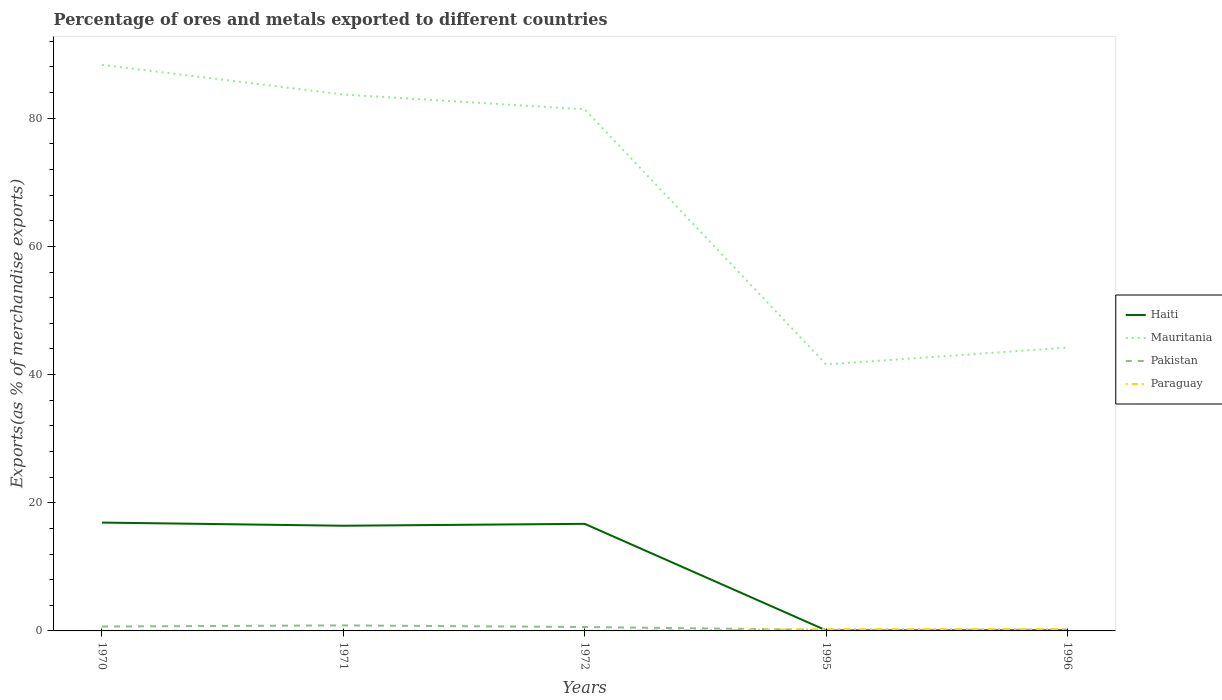Across all years, what is the maximum percentage of exports to different countries in Pakistan?
Offer a very short reply. 0.16. What is the total percentage of exports to different countries in Pakistan in the graph?
Give a very brief answer. -0.06. What is the difference between the highest and the second highest percentage of exports to different countries in Haiti?
Your answer should be compact. 16.82. What is the difference between the highest and the lowest percentage of exports to different countries in Mauritania?
Your answer should be very brief. 3. Where does the legend appear in the graph?
Offer a very short reply. Center right. How are the legend labels stacked?
Keep it short and to the point. Vertical. What is the title of the graph?
Ensure brevity in your answer.  Percentage of ores and metals exported to different countries. Does "Cameroon" appear as one of the legend labels in the graph?
Your answer should be compact. No. What is the label or title of the Y-axis?
Your answer should be very brief. Exports(as % of merchandise exports). What is the Exports(as % of merchandise exports) in Haiti in 1970?
Your answer should be compact. 16.91. What is the Exports(as % of merchandise exports) of Mauritania in 1970?
Your answer should be compact. 88.32. What is the Exports(as % of merchandise exports) in Pakistan in 1970?
Your response must be concise. 0.69. What is the Exports(as % of merchandise exports) in Paraguay in 1970?
Give a very brief answer. 0.03. What is the Exports(as % of merchandise exports) of Haiti in 1971?
Your answer should be compact. 16.41. What is the Exports(as % of merchandise exports) of Mauritania in 1971?
Make the answer very short. 83.7. What is the Exports(as % of merchandise exports) of Pakistan in 1971?
Offer a very short reply. 0.86. What is the Exports(as % of merchandise exports) of Paraguay in 1971?
Provide a short and direct response. 0.02. What is the Exports(as % of merchandise exports) in Haiti in 1972?
Make the answer very short. 16.71. What is the Exports(as % of merchandise exports) in Mauritania in 1972?
Ensure brevity in your answer.  81.38. What is the Exports(as % of merchandise exports) of Pakistan in 1972?
Provide a succinct answer. 0.61. What is the Exports(as % of merchandise exports) in Paraguay in 1972?
Make the answer very short. 0. What is the Exports(as % of merchandise exports) in Haiti in 1995?
Your answer should be compact. 0.09. What is the Exports(as % of merchandise exports) in Mauritania in 1995?
Your answer should be compact. 41.58. What is the Exports(as % of merchandise exports) in Pakistan in 1995?
Your answer should be very brief. 0.16. What is the Exports(as % of merchandise exports) of Paraguay in 1995?
Your response must be concise. 0.27. What is the Exports(as % of merchandise exports) of Haiti in 1996?
Make the answer very short. 0.1. What is the Exports(as % of merchandise exports) of Mauritania in 1996?
Offer a terse response. 44.21. What is the Exports(as % of merchandise exports) of Pakistan in 1996?
Offer a very short reply. 0.22. What is the Exports(as % of merchandise exports) of Paraguay in 1996?
Offer a terse response. 0.28. Across all years, what is the maximum Exports(as % of merchandise exports) in Haiti?
Offer a terse response. 16.91. Across all years, what is the maximum Exports(as % of merchandise exports) of Mauritania?
Your answer should be very brief. 88.32. Across all years, what is the maximum Exports(as % of merchandise exports) of Pakistan?
Make the answer very short. 0.86. Across all years, what is the maximum Exports(as % of merchandise exports) in Paraguay?
Make the answer very short. 0.28. Across all years, what is the minimum Exports(as % of merchandise exports) of Haiti?
Your response must be concise. 0.09. Across all years, what is the minimum Exports(as % of merchandise exports) in Mauritania?
Ensure brevity in your answer.  41.58. Across all years, what is the minimum Exports(as % of merchandise exports) of Pakistan?
Make the answer very short. 0.16. Across all years, what is the minimum Exports(as % of merchandise exports) of Paraguay?
Your response must be concise. 0. What is the total Exports(as % of merchandise exports) in Haiti in the graph?
Your response must be concise. 50.21. What is the total Exports(as % of merchandise exports) of Mauritania in the graph?
Ensure brevity in your answer.  339.2. What is the total Exports(as % of merchandise exports) of Pakistan in the graph?
Offer a terse response. 2.54. What is the total Exports(as % of merchandise exports) of Paraguay in the graph?
Offer a terse response. 0.61. What is the difference between the Exports(as % of merchandise exports) in Haiti in 1970 and that in 1971?
Your answer should be very brief. 0.49. What is the difference between the Exports(as % of merchandise exports) in Mauritania in 1970 and that in 1971?
Your answer should be very brief. 4.62. What is the difference between the Exports(as % of merchandise exports) in Pakistan in 1970 and that in 1971?
Keep it short and to the point. -0.17. What is the difference between the Exports(as % of merchandise exports) of Paraguay in 1970 and that in 1971?
Give a very brief answer. 0.01. What is the difference between the Exports(as % of merchandise exports) in Haiti in 1970 and that in 1972?
Keep it short and to the point. 0.2. What is the difference between the Exports(as % of merchandise exports) in Mauritania in 1970 and that in 1972?
Provide a succinct answer. 6.94. What is the difference between the Exports(as % of merchandise exports) of Pakistan in 1970 and that in 1972?
Ensure brevity in your answer.  0.07. What is the difference between the Exports(as % of merchandise exports) in Paraguay in 1970 and that in 1972?
Provide a short and direct response. 0.03. What is the difference between the Exports(as % of merchandise exports) of Haiti in 1970 and that in 1995?
Provide a short and direct response. 16.82. What is the difference between the Exports(as % of merchandise exports) in Mauritania in 1970 and that in 1995?
Make the answer very short. 46.74. What is the difference between the Exports(as % of merchandise exports) of Pakistan in 1970 and that in 1995?
Your answer should be very brief. 0.52. What is the difference between the Exports(as % of merchandise exports) in Paraguay in 1970 and that in 1995?
Make the answer very short. -0.24. What is the difference between the Exports(as % of merchandise exports) of Haiti in 1970 and that in 1996?
Your answer should be very brief. 16.81. What is the difference between the Exports(as % of merchandise exports) of Mauritania in 1970 and that in 1996?
Make the answer very short. 44.11. What is the difference between the Exports(as % of merchandise exports) of Pakistan in 1970 and that in 1996?
Give a very brief answer. 0.46. What is the difference between the Exports(as % of merchandise exports) of Paraguay in 1970 and that in 1996?
Ensure brevity in your answer.  -0.25. What is the difference between the Exports(as % of merchandise exports) in Haiti in 1971 and that in 1972?
Give a very brief answer. -0.29. What is the difference between the Exports(as % of merchandise exports) in Mauritania in 1971 and that in 1972?
Ensure brevity in your answer.  2.32. What is the difference between the Exports(as % of merchandise exports) of Pakistan in 1971 and that in 1972?
Give a very brief answer. 0.25. What is the difference between the Exports(as % of merchandise exports) of Paraguay in 1971 and that in 1972?
Offer a terse response. 0.02. What is the difference between the Exports(as % of merchandise exports) of Haiti in 1971 and that in 1995?
Offer a very short reply. 16.33. What is the difference between the Exports(as % of merchandise exports) in Mauritania in 1971 and that in 1995?
Your answer should be compact. 42.12. What is the difference between the Exports(as % of merchandise exports) in Pakistan in 1971 and that in 1995?
Make the answer very short. 0.7. What is the difference between the Exports(as % of merchandise exports) of Paraguay in 1971 and that in 1995?
Provide a succinct answer. -0.25. What is the difference between the Exports(as % of merchandise exports) of Haiti in 1971 and that in 1996?
Offer a very short reply. 16.32. What is the difference between the Exports(as % of merchandise exports) of Mauritania in 1971 and that in 1996?
Provide a short and direct response. 39.48. What is the difference between the Exports(as % of merchandise exports) in Pakistan in 1971 and that in 1996?
Ensure brevity in your answer.  0.64. What is the difference between the Exports(as % of merchandise exports) in Paraguay in 1971 and that in 1996?
Make the answer very short. -0.26. What is the difference between the Exports(as % of merchandise exports) of Haiti in 1972 and that in 1995?
Ensure brevity in your answer.  16.62. What is the difference between the Exports(as % of merchandise exports) in Mauritania in 1972 and that in 1995?
Offer a terse response. 39.8. What is the difference between the Exports(as % of merchandise exports) of Pakistan in 1972 and that in 1995?
Offer a very short reply. 0.45. What is the difference between the Exports(as % of merchandise exports) in Paraguay in 1972 and that in 1995?
Ensure brevity in your answer.  -0.27. What is the difference between the Exports(as % of merchandise exports) of Haiti in 1972 and that in 1996?
Your answer should be very brief. 16.61. What is the difference between the Exports(as % of merchandise exports) of Mauritania in 1972 and that in 1996?
Your answer should be compact. 37.17. What is the difference between the Exports(as % of merchandise exports) in Pakistan in 1972 and that in 1996?
Provide a short and direct response. 0.39. What is the difference between the Exports(as % of merchandise exports) of Paraguay in 1972 and that in 1996?
Give a very brief answer. -0.28. What is the difference between the Exports(as % of merchandise exports) of Haiti in 1995 and that in 1996?
Your response must be concise. -0.01. What is the difference between the Exports(as % of merchandise exports) of Mauritania in 1995 and that in 1996?
Offer a terse response. -2.63. What is the difference between the Exports(as % of merchandise exports) of Pakistan in 1995 and that in 1996?
Give a very brief answer. -0.06. What is the difference between the Exports(as % of merchandise exports) of Paraguay in 1995 and that in 1996?
Your answer should be very brief. -0.01. What is the difference between the Exports(as % of merchandise exports) of Haiti in 1970 and the Exports(as % of merchandise exports) of Mauritania in 1971?
Your answer should be compact. -66.79. What is the difference between the Exports(as % of merchandise exports) of Haiti in 1970 and the Exports(as % of merchandise exports) of Pakistan in 1971?
Give a very brief answer. 16.05. What is the difference between the Exports(as % of merchandise exports) of Haiti in 1970 and the Exports(as % of merchandise exports) of Paraguay in 1971?
Provide a short and direct response. 16.88. What is the difference between the Exports(as % of merchandise exports) in Mauritania in 1970 and the Exports(as % of merchandise exports) in Pakistan in 1971?
Your response must be concise. 87.46. What is the difference between the Exports(as % of merchandise exports) of Mauritania in 1970 and the Exports(as % of merchandise exports) of Paraguay in 1971?
Provide a succinct answer. 88.3. What is the difference between the Exports(as % of merchandise exports) in Pakistan in 1970 and the Exports(as % of merchandise exports) in Paraguay in 1971?
Make the answer very short. 0.66. What is the difference between the Exports(as % of merchandise exports) of Haiti in 1970 and the Exports(as % of merchandise exports) of Mauritania in 1972?
Make the answer very short. -64.48. What is the difference between the Exports(as % of merchandise exports) of Haiti in 1970 and the Exports(as % of merchandise exports) of Pakistan in 1972?
Your response must be concise. 16.29. What is the difference between the Exports(as % of merchandise exports) of Haiti in 1970 and the Exports(as % of merchandise exports) of Paraguay in 1972?
Your answer should be compact. 16.9. What is the difference between the Exports(as % of merchandise exports) in Mauritania in 1970 and the Exports(as % of merchandise exports) in Pakistan in 1972?
Keep it short and to the point. 87.71. What is the difference between the Exports(as % of merchandise exports) of Mauritania in 1970 and the Exports(as % of merchandise exports) of Paraguay in 1972?
Your answer should be very brief. 88.32. What is the difference between the Exports(as % of merchandise exports) of Pakistan in 1970 and the Exports(as % of merchandise exports) of Paraguay in 1972?
Give a very brief answer. 0.68. What is the difference between the Exports(as % of merchandise exports) in Haiti in 1970 and the Exports(as % of merchandise exports) in Mauritania in 1995?
Ensure brevity in your answer.  -24.67. What is the difference between the Exports(as % of merchandise exports) in Haiti in 1970 and the Exports(as % of merchandise exports) in Pakistan in 1995?
Offer a very short reply. 16.74. What is the difference between the Exports(as % of merchandise exports) of Haiti in 1970 and the Exports(as % of merchandise exports) of Paraguay in 1995?
Your answer should be very brief. 16.63. What is the difference between the Exports(as % of merchandise exports) in Mauritania in 1970 and the Exports(as % of merchandise exports) in Pakistan in 1995?
Offer a terse response. 88.16. What is the difference between the Exports(as % of merchandise exports) in Mauritania in 1970 and the Exports(as % of merchandise exports) in Paraguay in 1995?
Make the answer very short. 88.05. What is the difference between the Exports(as % of merchandise exports) of Pakistan in 1970 and the Exports(as % of merchandise exports) of Paraguay in 1995?
Give a very brief answer. 0.41. What is the difference between the Exports(as % of merchandise exports) in Haiti in 1970 and the Exports(as % of merchandise exports) in Mauritania in 1996?
Your answer should be very brief. -27.31. What is the difference between the Exports(as % of merchandise exports) in Haiti in 1970 and the Exports(as % of merchandise exports) in Pakistan in 1996?
Give a very brief answer. 16.68. What is the difference between the Exports(as % of merchandise exports) in Haiti in 1970 and the Exports(as % of merchandise exports) in Paraguay in 1996?
Your answer should be compact. 16.62. What is the difference between the Exports(as % of merchandise exports) of Mauritania in 1970 and the Exports(as % of merchandise exports) of Pakistan in 1996?
Your response must be concise. 88.1. What is the difference between the Exports(as % of merchandise exports) of Mauritania in 1970 and the Exports(as % of merchandise exports) of Paraguay in 1996?
Ensure brevity in your answer.  88.04. What is the difference between the Exports(as % of merchandise exports) of Pakistan in 1970 and the Exports(as % of merchandise exports) of Paraguay in 1996?
Keep it short and to the point. 0.4. What is the difference between the Exports(as % of merchandise exports) in Haiti in 1971 and the Exports(as % of merchandise exports) in Mauritania in 1972?
Offer a terse response. -64.97. What is the difference between the Exports(as % of merchandise exports) of Haiti in 1971 and the Exports(as % of merchandise exports) of Pakistan in 1972?
Make the answer very short. 15.8. What is the difference between the Exports(as % of merchandise exports) of Haiti in 1971 and the Exports(as % of merchandise exports) of Paraguay in 1972?
Ensure brevity in your answer.  16.41. What is the difference between the Exports(as % of merchandise exports) of Mauritania in 1971 and the Exports(as % of merchandise exports) of Pakistan in 1972?
Your response must be concise. 83.09. What is the difference between the Exports(as % of merchandise exports) of Mauritania in 1971 and the Exports(as % of merchandise exports) of Paraguay in 1972?
Your answer should be compact. 83.7. What is the difference between the Exports(as % of merchandise exports) in Pakistan in 1971 and the Exports(as % of merchandise exports) in Paraguay in 1972?
Offer a terse response. 0.86. What is the difference between the Exports(as % of merchandise exports) of Haiti in 1971 and the Exports(as % of merchandise exports) of Mauritania in 1995?
Ensure brevity in your answer.  -25.17. What is the difference between the Exports(as % of merchandise exports) in Haiti in 1971 and the Exports(as % of merchandise exports) in Pakistan in 1995?
Keep it short and to the point. 16.25. What is the difference between the Exports(as % of merchandise exports) in Haiti in 1971 and the Exports(as % of merchandise exports) in Paraguay in 1995?
Your answer should be very brief. 16.14. What is the difference between the Exports(as % of merchandise exports) of Mauritania in 1971 and the Exports(as % of merchandise exports) of Pakistan in 1995?
Your answer should be very brief. 83.54. What is the difference between the Exports(as % of merchandise exports) in Mauritania in 1971 and the Exports(as % of merchandise exports) in Paraguay in 1995?
Provide a short and direct response. 83.42. What is the difference between the Exports(as % of merchandise exports) in Pakistan in 1971 and the Exports(as % of merchandise exports) in Paraguay in 1995?
Offer a terse response. 0.58. What is the difference between the Exports(as % of merchandise exports) of Haiti in 1971 and the Exports(as % of merchandise exports) of Mauritania in 1996?
Make the answer very short. -27.8. What is the difference between the Exports(as % of merchandise exports) in Haiti in 1971 and the Exports(as % of merchandise exports) in Pakistan in 1996?
Your response must be concise. 16.19. What is the difference between the Exports(as % of merchandise exports) of Haiti in 1971 and the Exports(as % of merchandise exports) of Paraguay in 1996?
Provide a short and direct response. 16.13. What is the difference between the Exports(as % of merchandise exports) in Mauritania in 1971 and the Exports(as % of merchandise exports) in Pakistan in 1996?
Provide a short and direct response. 83.48. What is the difference between the Exports(as % of merchandise exports) of Mauritania in 1971 and the Exports(as % of merchandise exports) of Paraguay in 1996?
Keep it short and to the point. 83.42. What is the difference between the Exports(as % of merchandise exports) of Pakistan in 1971 and the Exports(as % of merchandise exports) of Paraguay in 1996?
Provide a short and direct response. 0.58. What is the difference between the Exports(as % of merchandise exports) of Haiti in 1972 and the Exports(as % of merchandise exports) of Mauritania in 1995?
Ensure brevity in your answer.  -24.87. What is the difference between the Exports(as % of merchandise exports) in Haiti in 1972 and the Exports(as % of merchandise exports) in Pakistan in 1995?
Offer a terse response. 16.54. What is the difference between the Exports(as % of merchandise exports) in Haiti in 1972 and the Exports(as % of merchandise exports) in Paraguay in 1995?
Offer a very short reply. 16.43. What is the difference between the Exports(as % of merchandise exports) in Mauritania in 1972 and the Exports(as % of merchandise exports) in Pakistan in 1995?
Your answer should be compact. 81.22. What is the difference between the Exports(as % of merchandise exports) in Mauritania in 1972 and the Exports(as % of merchandise exports) in Paraguay in 1995?
Ensure brevity in your answer.  81.11. What is the difference between the Exports(as % of merchandise exports) in Pakistan in 1972 and the Exports(as % of merchandise exports) in Paraguay in 1995?
Your answer should be compact. 0.34. What is the difference between the Exports(as % of merchandise exports) in Haiti in 1972 and the Exports(as % of merchandise exports) in Mauritania in 1996?
Your response must be concise. -27.51. What is the difference between the Exports(as % of merchandise exports) in Haiti in 1972 and the Exports(as % of merchandise exports) in Pakistan in 1996?
Ensure brevity in your answer.  16.49. What is the difference between the Exports(as % of merchandise exports) in Haiti in 1972 and the Exports(as % of merchandise exports) in Paraguay in 1996?
Ensure brevity in your answer.  16.43. What is the difference between the Exports(as % of merchandise exports) in Mauritania in 1972 and the Exports(as % of merchandise exports) in Pakistan in 1996?
Ensure brevity in your answer.  81.16. What is the difference between the Exports(as % of merchandise exports) of Mauritania in 1972 and the Exports(as % of merchandise exports) of Paraguay in 1996?
Offer a very short reply. 81.1. What is the difference between the Exports(as % of merchandise exports) of Pakistan in 1972 and the Exports(as % of merchandise exports) of Paraguay in 1996?
Make the answer very short. 0.33. What is the difference between the Exports(as % of merchandise exports) of Haiti in 1995 and the Exports(as % of merchandise exports) of Mauritania in 1996?
Offer a very short reply. -44.13. What is the difference between the Exports(as % of merchandise exports) in Haiti in 1995 and the Exports(as % of merchandise exports) in Pakistan in 1996?
Provide a short and direct response. -0.13. What is the difference between the Exports(as % of merchandise exports) in Haiti in 1995 and the Exports(as % of merchandise exports) in Paraguay in 1996?
Give a very brief answer. -0.19. What is the difference between the Exports(as % of merchandise exports) in Mauritania in 1995 and the Exports(as % of merchandise exports) in Pakistan in 1996?
Give a very brief answer. 41.36. What is the difference between the Exports(as % of merchandise exports) of Mauritania in 1995 and the Exports(as % of merchandise exports) of Paraguay in 1996?
Ensure brevity in your answer.  41.3. What is the difference between the Exports(as % of merchandise exports) in Pakistan in 1995 and the Exports(as % of merchandise exports) in Paraguay in 1996?
Keep it short and to the point. -0.12. What is the average Exports(as % of merchandise exports) in Haiti per year?
Offer a terse response. 10.04. What is the average Exports(as % of merchandise exports) of Mauritania per year?
Provide a short and direct response. 67.84. What is the average Exports(as % of merchandise exports) in Pakistan per year?
Offer a terse response. 0.51. What is the average Exports(as % of merchandise exports) in Paraguay per year?
Your response must be concise. 0.12. In the year 1970, what is the difference between the Exports(as % of merchandise exports) of Haiti and Exports(as % of merchandise exports) of Mauritania?
Give a very brief answer. -71.42. In the year 1970, what is the difference between the Exports(as % of merchandise exports) in Haiti and Exports(as % of merchandise exports) in Pakistan?
Your response must be concise. 16.22. In the year 1970, what is the difference between the Exports(as % of merchandise exports) of Haiti and Exports(as % of merchandise exports) of Paraguay?
Your response must be concise. 16.87. In the year 1970, what is the difference between the Exports(as % of merchandise exports) of Mauritania and Exports(as % of merchandise exports) of Pakistan?
Your answer should be compact. 87.63. In the year 1970, what is the difference between the Exports(as % of merchandise exports) in Mauritania and Exports(as % of merchandise exports) in Paraguay?
Your answer should be very brief. 88.29. In the year 1970, what is the difference between the Exports(as % of merchandise exports) of Pakistan and Exports(as % of merchandise exports) of Paraguay?
Your response must be concise. 0.65. In the year 1971, what is the difference between the Exports(as % of merchandise exports) in Haiti and Exports(as % of merchandise exports) in Mauritania?
Ensure brevity in your answer.  -67.28. In the year 1971, what is the difference between the Exports(as % of merchandise exports) in Haiti and Exports(as % of merchandise exports) in Pakistan?
Keep it short and to the point. 15.56. In the year 1971, what is the difference between the Exports(as % of merchandise exports) in Haiti and Exports(as % of merchandise exports) in Paraguay?
Make the answer very short. 16.39. In the year 1971, what is the difference between the Exports(as % of merchandise exports) in Mauritania and Exports(as % of merchandise exports) in Pakistan?
Ensure brevity in your answer.  82.84. In the year 1971, what is the difference between the Exports(as % of merchandise exports) of Mauritania and Exports(as % of merchandise exports) of Paraguay?
Provide a short and direct response. 83.68. In the year 1971, what is the difference between the Exports(as % of merchandise exports) of Pakistan and Exports(as % of merchandise exports) of Paraguay?
Give a very brief answer. 0.84. In the year 1972, what is the difference between the Exports(as % of merchandise exports) in Haiti and Exports(as % of merchandise exports) in Mauritania?
Ensure brevity in your answer.  -64.68. In the year 1972, what is the difference between the Exports(as % of merchandise exports) of Haiti and Exports(as % of merchandise exports) of Pakistan?
Make the answer very short. 16.09. In the year 1972, what is the difference between the Exports(as % of merchandise exports) in Haiti and Exports(as % of merchandise exports) in Paraguay?
Provide a succinct answer. 16.7. In the year 1972, what is the difference between the Exports(as % of merchandise exports) in Mauritania and Exports(as % of merchandise exports) in Pakistan?
Ensure brevity in your answer.  80.77. In the year 1972, what is the difference between the Exports(as % of merchandise exports) in Mauritania and Exports(as % of merchandise exports) in Paraguay?
Provide a succinct answer. 81.38. In the year 1972, what is the difference between the Exports(as % of merchandise exports) in Pakistan and Exports(as % of merchandise exports) in Paraguay?
Your answer should be compact. 0.61. In the year 1995, what is the difference between the Exports(as % of merchandise exports) in Haiti and Exports(as % of merchandise exports) in Mauritania?
Your response must be concise. -41.49. In the year 1995, what is the difference between the Exports(as % of merchandise exports) in Haiti and Exports(as % of merchandise exports) in Pakistan?
Your answer should be compact. -0.07. In the year 1995, what is the difference between the Exports(as % of merchandise exports) in Haiti and Exports(as % of merchandise exports) in Paraguay?
Your answer should be compact. -0.19. In the year 1995, what is the difference between the Exports(as % of merchandise exports) in Mauritania and Exports(as % of merchandise exports) in Pakistan?
Give a very brief answer. 41.42. In the year 1995, what is the difference between the Exports(as % of merchandise exports) of Mauritania and Exports(as % of merchandise exports) of Paraguay?
Give a very brief answer. 41.3. In the year 1995, what is the difference between the Exports(as % of merchandise exports) in Pakistan and Exports(as % of merchandise exports) in Paraguay?
Make the answer very short. -0.11. In the year 1996, what is the difference between the Exports(as % of merchandise exports) of Haiti and Exports(as % of merchandise exports) of Mauritania?
Offer a very short reply. -44.12. In the year 1996, what is the difference between the Exports(as % of merchandise exports) in Haiti and Exports(as % of merchandise exports) in Pakistan?
Provide a succinct answer. -0.12. In the year 1996, what is the difference between the Exports(as % of merchandise exports) in Haiti and Exports(as % of merchandise exports) in Paraguay?
Keep it short and to the point. -0.18. In the year 1996, what is the difference between the Exports(as % of merchandise exports) in Mauritania and Exports(as % of merchandise exports) in Pakistan?
Keep it short and to the point. 43.99. In the year 1996, what is the difference between the Exports(as % of merchandise exports) in Mauritania and Exports(as % of merchandise exports) in Paraguay?
Provide a short and direct response. 43.93. In the year 1996, what is the difference between the Exports(as % of merchandise exports) of Pakistan and Exports(as % of merchandise exports) of Paraguay?
Your answer should be very brief. -0.06. What is the ratio of the Exports(as % of merchandise exports) of Haiti in 1970 to that in 1971?
Keep it short and to the point. 1.03. What is the ratio of the Exports(as % of merchandise exports) of Mauritania in 1970 to that in 1971?
Offer a terse response. 1.06. What is the ratio of the Exports(as % of merchandise exports) in Pakistan in 1970 to that in 1971?
Keep it short and to the point. 0.8. What is the ratio of the Exports(as % of merchandise exports) of Paraguay in 1970 to that in 1971?
Offer a very short reply. 1.44. What is the ratio of the Exports(as % of merchandise exports) of Haiti in 1970 to that in 1972?
Keep it short and to the point. 1.01. What is the ratio of the Exports(as % of merchandise exports) of Mauritania in 1970 to that in 1972?
Your answer should be compact. 1.09. What is the ratio of the Exports(as % of merchandise exports) of Pakistan in 1970 to that in 1972?
Provide a short and direct response. 1.12. What is the ratio of the Exports(as % of merchandise exports) in Paraguay in 1970 to that in 1972?
Give a very brief answer. 10.98. What is the ratio of the Exports(as % of merchandise exports) in Haiti in 1970 to that in 1995?
Make the answer very short. 191.84. What is the ratio of the Exports(as % of merchandise exports) of Mauritania in 1970 to that in 1995?
Give a very brief answer. 2.12. What is the ratio of the Exports(as % of merchandise exports) in Pakistan in 1970 to that in 1995?
Ensure brevity in your answer.  4.22. What is the ratio of the Exports(as % of merchandise exports) of Paraguay in 1970 to that in 1995?
Keep it short and to the point. 0.12. What is the ratio of the Exports(as % of merchandise exports) of Haiti in 1970 to that in 1996?
Provide a succinct answer. 175. What is the ratio of the Exports(as % of merchandise exports) of Mauritania in 1970 to that in 1996?
Ensure brevity in your answer.  2. What is the ratio of the Exports(as % of merchandise exports) in Pakistan in 1970 to that in 1996?
Provide a short and direct response. 3.1. What is the ratio of the Exports(as % of merchandise exports) in Paraguay in 1970 to that in 1996?
Provide a short and direct response. 0.11. What is the ratio of the Exports(as % of merchandise exports) in Haiti in 1971 to that in 1972?
Your answer should be very brief. 0.98. What is the ratio of the Exports(as % of merchandise exports) of Mauritania in 1971 to that in 1972?
Make the answer very short. 1.03. What is the ratio of the Exports(as % of merchandise exports) of Pakistan in 1971 to that in 1972?
Offer a terse response. 1.4. What is the ratio of the Exports(as % of merchandise exports) of Paraguay in 1971 to that in 1972?
Your answer should be compact. 7.62. What is the ratio of the Exports(as % of merchandise exports) in Haiti in 1971 to that in 1995?
Your answer should be very brief. 186.26. What is the ratio of the Exports(as % of merchandise exports) of Mauritania in 1971 to that in 1995?
Provide a short and direct response. 2.01. What is the ratio of the Exports(as % of merchandise exports) in Pakistan in 1971 to that in 1995?
Ensure brevity in your answer.  5.28. What is the ratio of the Exports(as % of merchandise exports) of Paraguay in 1971 to that in 1995?
Offer a terse response. 0.08. What is the ratio of the Exports(as % of merchandise exports) in Haiti in 1971 to that in 1996?
Provide a succinct answer. 169.91. What is the ratio of the Exports(as % of merchandise exports) in Mauritania in 1971 to that in 1996?
Offer a very short reply. 1.89. What is the ratio of the Exports(as % of merchandise exports) of Pakistan in 1971 to that in 1996?
Give a very brief answer. 3.88. What is the ratio of the Exports(as % of merchandise exports) in Paraguay in 1971 to that in 1996?
Make the answer very short. 0.08. What is the ratio of the Exports(as % of merchandise exports) in Haiti in 1972 to that in 1995?
Keep it short and to the point. 189.59. What is the ratio of the Exports(as % of merchandise exports) of Mauritania in 1972 to that in 1995?
Your answer should be very brief. 1.96. What is the ratio of the Exports(as % of merchandise exports) of Pakistan in 1972 to that in 1995?
Provide a succinct answer. 3.77. What is the ratio of the Exports(as % of merchandise exports) in Paraguay in 1972 to that in 1995?
Your answer should be compact. 0.01. What is the ratio of the Exports(as % of merchandise exports) in Haiti in 1972 to that in 1996?
Make the answer very short. 172.95. What is the ratio of the Exports(as % of merchandise exports) in Mauritania in 1972 to that in 1996?
Your answer should be very brief. 1.84. What is the ratio of the Exports(as % of merchandise exports) of Pakistan in 1972 to that in 1996?
Ensure brevity in your answer.  2.76. What is the ratio of the Exports(as % of merchandise exports) of Paraguay in 1972 to that in 1996?
Provide a short and direct response. 0.01. What is the ratio of the Exports(as % of merchandise exports) of Haiti in 1995 to that in 1996?
Offer a terse response. 0.91. What is the ratio of the Exports(as % of merchandise exports) of Mauritania in 1995 to that in 1996?
Your response must be concise. 0.94. What is the ratio of the Exports(as % of merchandise exports) in Pakistan in 1995 to that in 1996?
Give a very brief answer. 0.73. What is the ratio of the Exports(as % of merchandise exports) in Paraguay in 1995 to that in 1996?
Provide a short and direct response. 0.98. What is the difference between the highest and the second highest Exports(as % of merchandise exports) in Haiti?
Provide a succinct answer. 0.2. What is the difference between the highest and the second highest Exports(as % of merchandise exports) in Mauritania?
Provide a succinct answer. 4.62. What is the difference between the highest and the second highest Exports(as % of merchandise exports) in Pakistan?
Your answer should be compact. 0.17. What is the difference between the highest and the second highest Exports(as % of merchandise exports) in Paraguay?
Keep it short and to the point. 0.01. What is the difference between the highest and the lowest Exports(as % of merchandise exports) in Haiti?
Your response must be concise. 16.82. What is the difference between the highest and the lowest Exports(as % of merchandise exports) of Mauritania?
Offer a terse response. 46.74. What is the difference between the highest and the lowest Exports(as % of merchandise exports) of Pakistan?
Provide a short and direct response. 0.7. What is the difference between the highest and the lowest Exports(as % of merchandise exports) in Paraguay?
Your answer should be very brief. 0.28. 